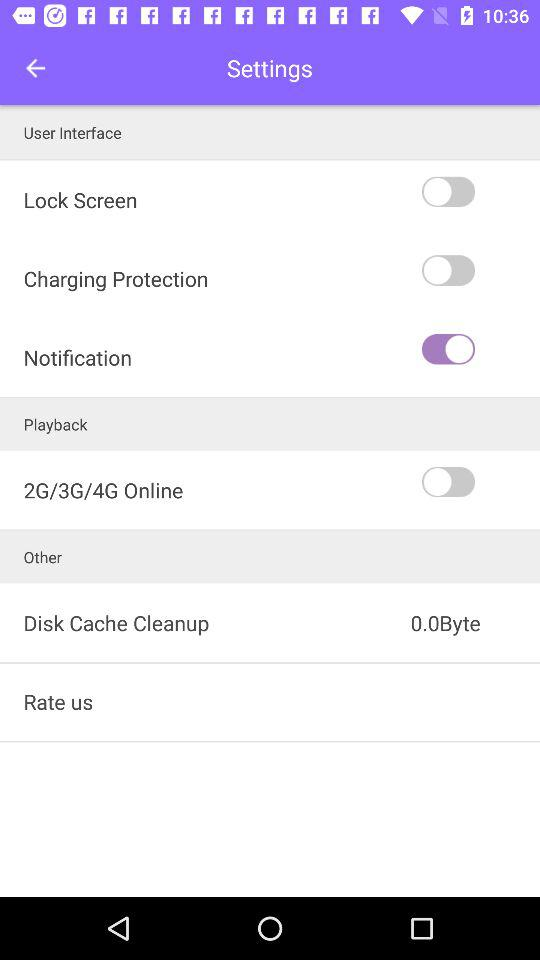What is the current status of the playback? The status is off. 